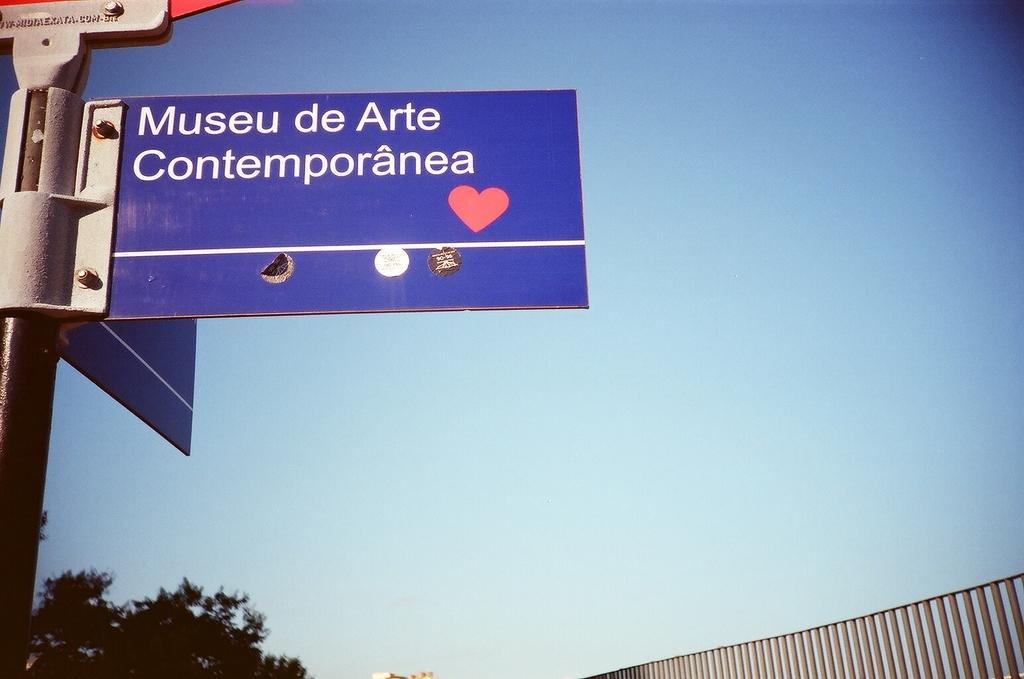<image>
Write a terse but informative summary of the picture. A street sign with Museu de Arte Contemporanea written on it 